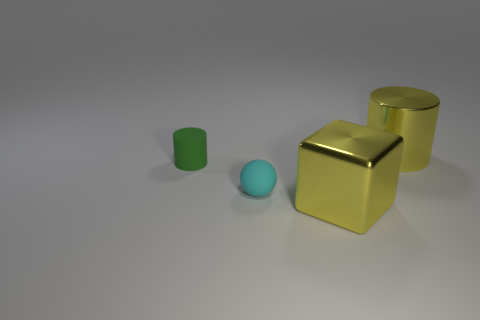Is the color of the large metallic cube the same as the cylinder that is right of the large yellow cube?
Your answer should be very brief. Yes. What number of things are blue things or big cylinders that are behind the cyan ball?
Provide a short and direct response. 1. Are there more green rubber cylinders behind the small cyan matte ball than yellow cylinders behind the large cylinder?
Provide a short and direct response. Yes. The object to the left of the small thing in front of the tiny object that is behind the tiny cyan thing is what shape?
Offer a terse response. Cylinder. What shape is the tiny green thing to the left of the object behind the green thing?
Offer a terse response. Cylinder. Is there a tiny thing made of the same material as the large yellow block?
Keep it short and to the point. No. How many cyan objects are either big objects or tiny matte things?
Provide a short and direct response. 1. Are there any shiny cubes that have the same color as the big metallic cylinder?
Ensure brevity in your answer.  Yes. What size is the yellow thing that is the same material as the big yellow block?
Offer a terse response. Large. What number of cylinders are blue metal objects or tiny green objects?
Offer a very short reply. 1. 